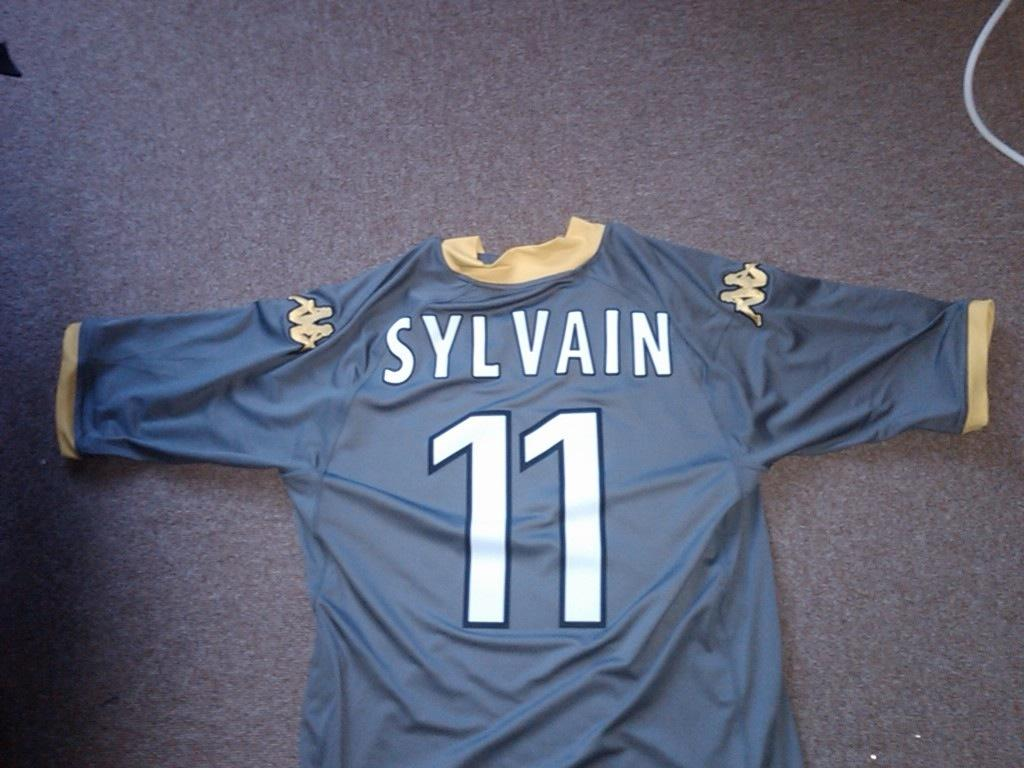<image>
Provide a brief description of the given image. a blue jersey number 11 Sylvain is spread out on the floor 